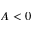Convert formula to latex. <formula><loc_0><loc_0><loc_500><loc_500>A < 0</formula> 